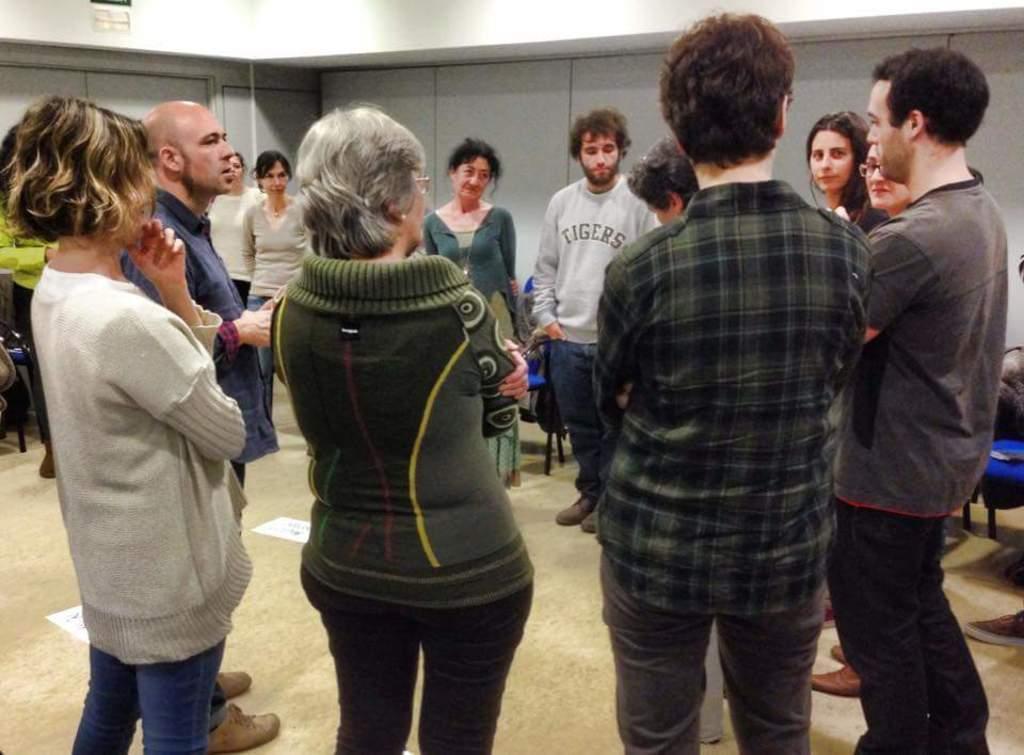Please provide a concise description of this image. At the bottom of this image, there are persons in different color dresses standing on a floor of a building. In the background, there are persons, chairs and documents on the floor and there is a wall. 